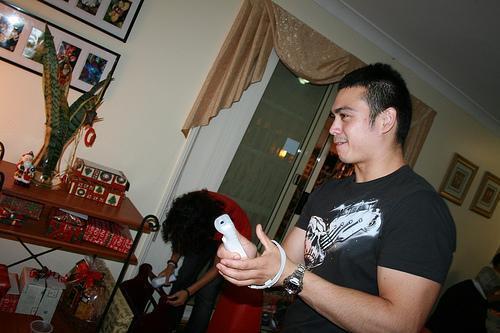How many people are there?
Give a very brief answer. 3. 